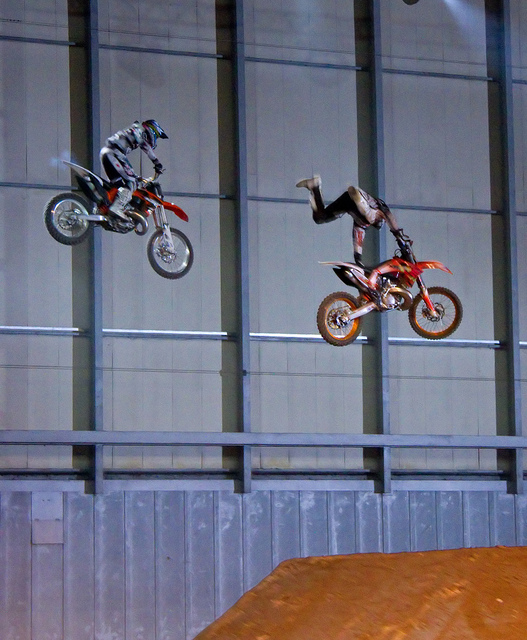How many motorcycles are there? There are exactly two motorcycles in the image, both of which are in mid-air performing what appears to be a stunt, with riders exhibiting skillful control and balance. 